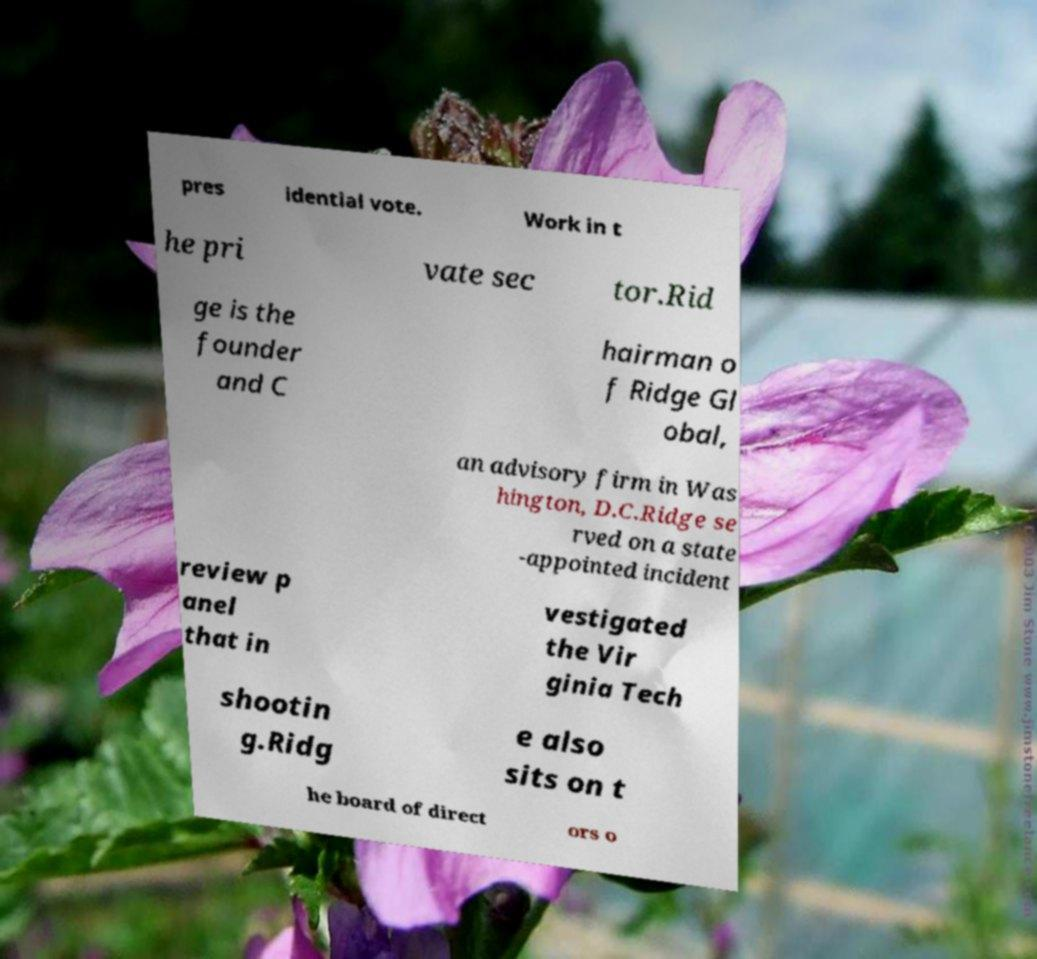Please identify and transcribe the text found in this image. pres idential vote. Work in t he pri vate sec tor.Rid ge is the founder and C hairman o f Ridge Gl obal, an advisory firm in Was hington, D.C.Ridge se rved on a state -appointed incident review p anel that in vestigated the Vir ginia Tech shootin g.Ridg e also sits on t he board of direct ors o 